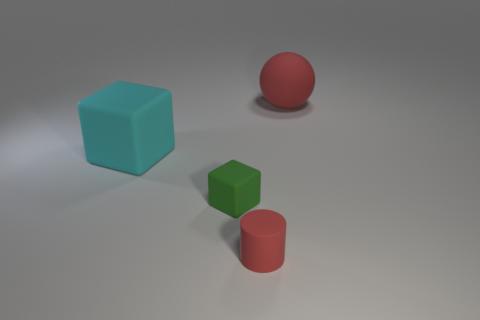Add 4 red rubber cylinders. How many objects exist? 8 Subtract all tiny cubes. Subtract all green metal blocks. How many objects are left? 3 Add 3 cyan matte blocks. How many cyan matte blocks are left? 4 Add 1 tiny purple metal things. How many tiny purple metal things exist? 1 Subtract 0 purple cubes. How many objects are left? 4 